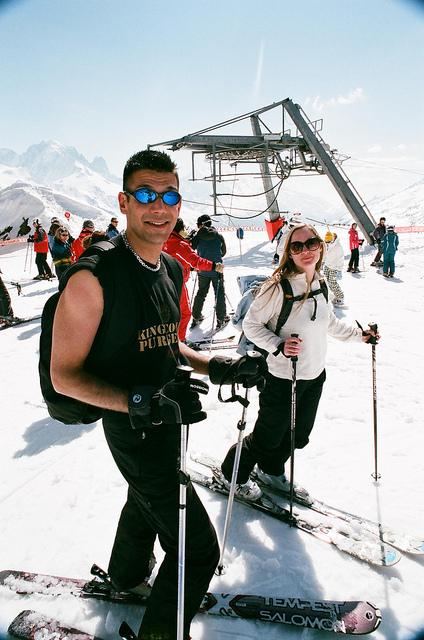Is the guy wearing a jacket?
Be succinct. No. Is the man wearing shades?
Be succinct. Yes. Are there mountains in the background?
Quick response, please. Yes. 